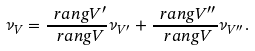Convert formula to latex. <formula><loc_0><loc_0><loc_500><loc_500>\nu _ { V } = \frac { \ r a n g V ^ { \prime } } { \ r a n g V } \nu _ { V ^ { \prime } } + \frac { \ r a n g V ^ { \prime \prime } } { \ r a n g V } \nu _ { V ^ { \prime \prime } } .</formula> 